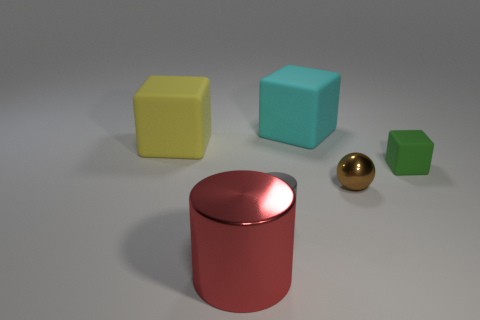Is there a large yellow cube that has the same material as the gray thing?
Give a very brief answer. No. What material is the green block that is the same size as the gray cylinder?
Keep it short and to the point. Rubber. There is a big matte cube right of the cube that is left of the big thing in front of the tiny green rubber object; what color is it?
Make the answer very short. Cyan. Is the shape of the big matte thing left of the large red metal object the same as the small thing left of the ball?
Make the answer very short. No. What number of green shiny blocks are there?
Provide a short and direct response. 0. There is a cylinder that is the same size as the cyan cube; what color is it?
Make the answer very short. Red. Is the large object in front of the small cube made of the same material as the thing behind the yellow matte cube?
Offer a very short reply. No. What is the size of the cube on the left side of the metallic cylinder that is in front of the gray thing?
Provide a short and direct response. Large. There is a cylinder in front of the small gray object; what is it made of?
Offer a terse response. Metal. What number of things are either blocks to the right of the small cylinder or large rubber objects on the right side of the yellow block?
Your answer should be very brief. 2. 